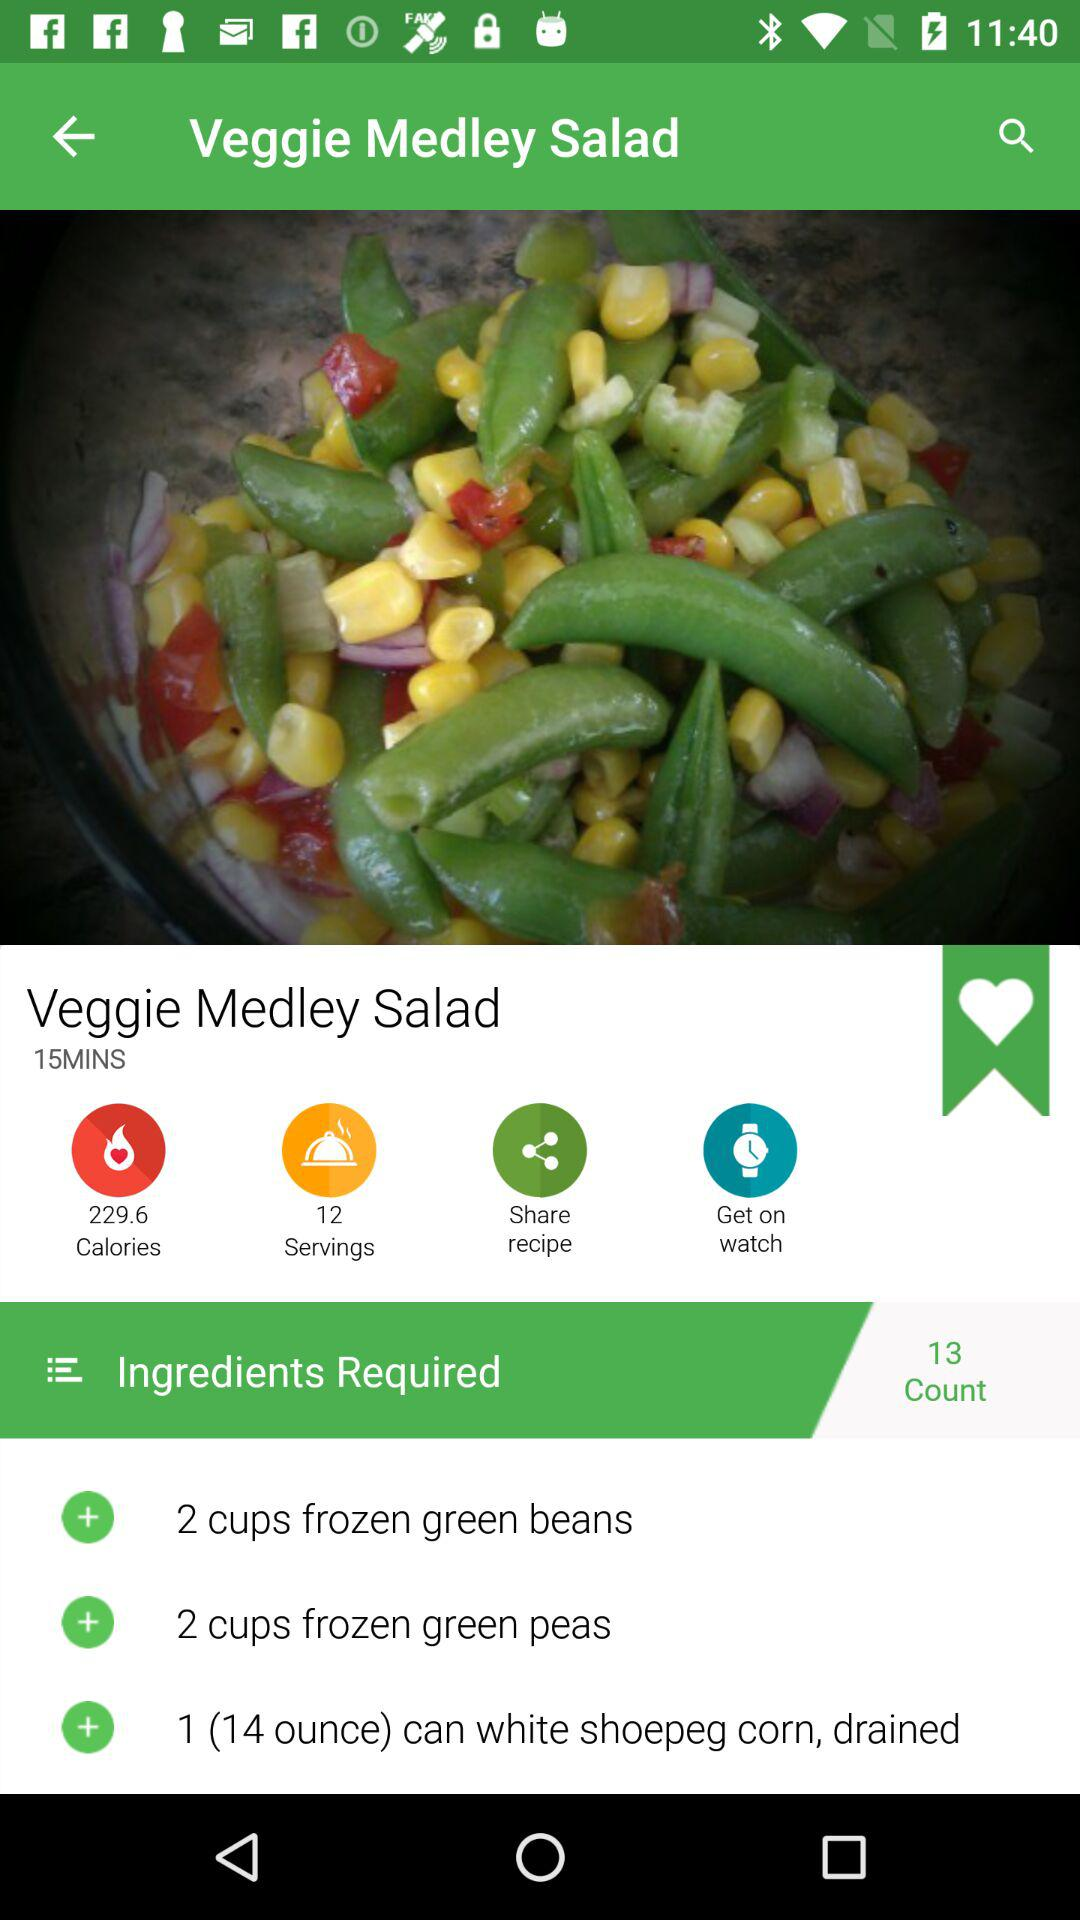How many more ingredients are required than servings?
Answer the question using a single word or phrase. 1 